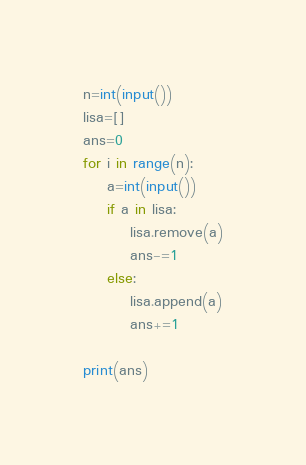<code> <loc_0><loc_0><loc_500><loc_500><_Python_>n=int(input())
lisa=[]
ans=0
for i in range(n):
    a=int(input())
    if a in lisa:
        lisa.remove(a)
        ans-=1
    else:
        lisa.append(a)
        ans+=1

print(ans)
</code> 